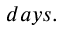<formula> <loc_0><loc_0><loc_500><loc_500>d a y s .</formula> 